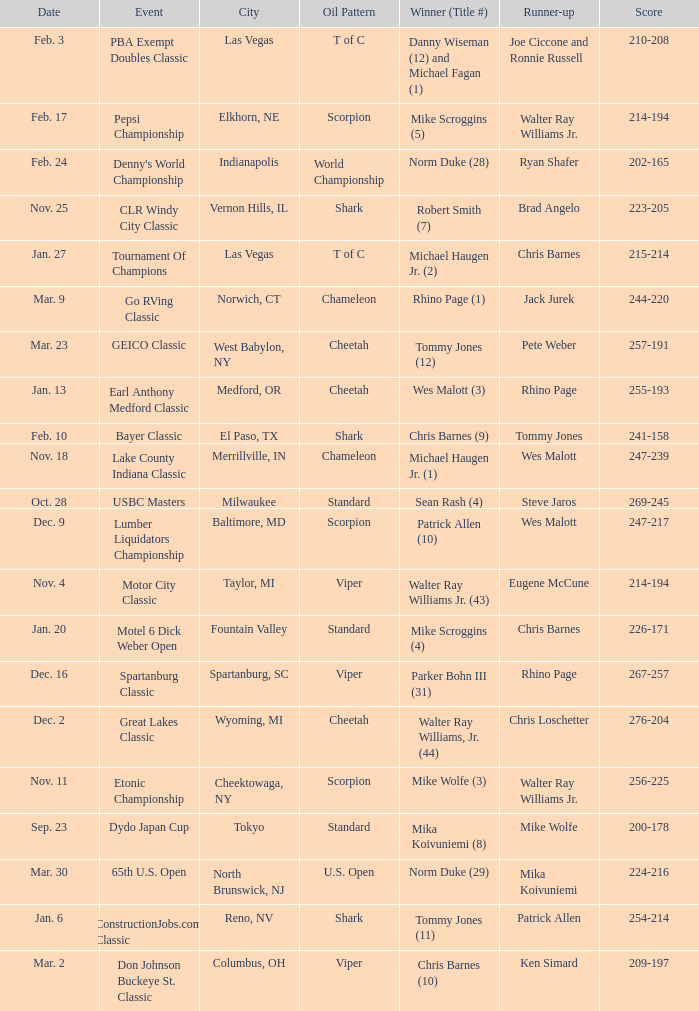Name the Event which has a Winner (Title #) of parker bohn iii (31)? Spartanburg Classic. 